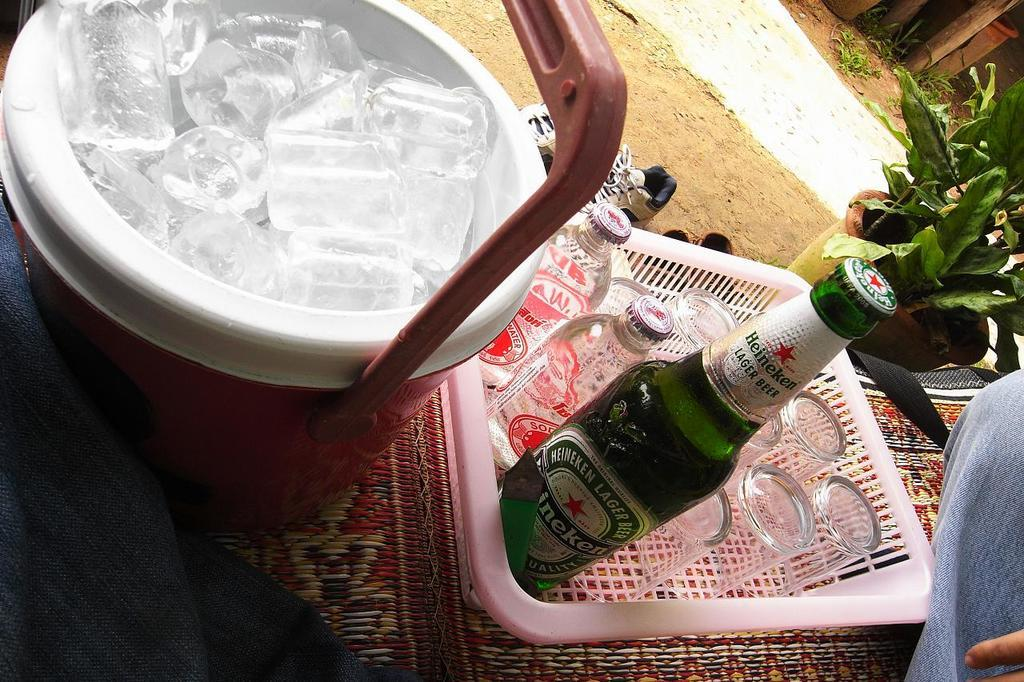What is in the bowl that is visible in the image? There is a bowl of ice in the image. What other items can be seen in the image besides the bowl of ice? There is a tray of glasses and bottles in the image. What can be seen in the background of the image? There is a plant and a path in the background of the image. What emotion does the frame in the image express? There is no frame present in the image, so it is not possible to determine the emotion it might express. 